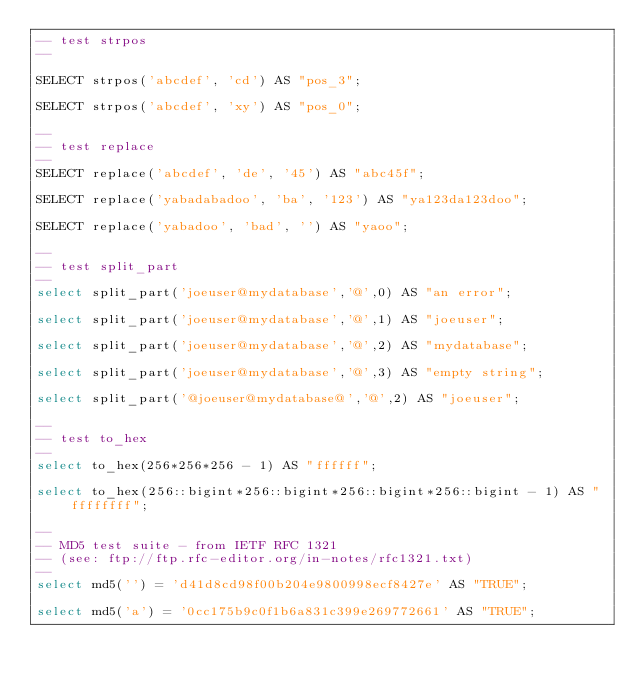<code> <loc_0><loc_0><loc_500><loc_500><_SQL_>-- test strpos
--

SELECT strpos('abcdef', 'cd') AS "pos_3";

SELECT strpos('abcdef', 'xy') AS "pos_0";

--
-- test replace
--
SELECT replace('abcdef', 'de', '45') AS "abc45f";

SELECT replace('yabadabadoo', 'ba', '123') AS "ya123da123doo";

SELECT replace('yabadoo', 'bad', '') AS "yaoo";

--
-- test split_part
--
select split_part('joeuser@mydatabase','@',0) AS "an error";

select split_part('joeuser@mydatabase','@',1) AS "joeuser";

select split_part('joeuser@mydatabase','@',2) AS "mydatabase";

select split_part('joeuser@mydatabase','@',3) AS "empty string";

select split_part('@joeuser@mydatabase@','@',2) AS "joeuser";

--
-- test to_hex
--
select to_hex(256*256*256 - 1) AS "ffffff";

select to_hex(256::bigint*256::bigint*256::bigint*256::bigint - 1) AS "ffffffff";

--
-- MD5 test suite - from IETF RFC 1321
-- (see: ftp://ftp.rfc-editor.org/in-notes/rfc1321.txt)
--
select md5('') = 'd41d8cd98f00b204e9800998ecf8427e' AS "TRUE";

select md5('a') = '0cc175b9c0f1b6a831c399e269772661' AS "TRUE";
</code> 